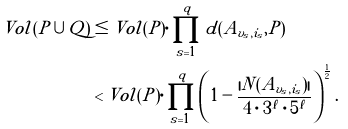<formula> <loc_0><loc_0><loc_500><loc_500>V o l ( P \cup Q ) & \leq V o l ( P ) \cdot \prod _ { s = 1 } ^ { q } d ( A _ { v _ { s } , i _ { s } } , P ) \\ & < V o l ( P ) \cdot \prod _ { s = 1 } ^ { q } \left ( 1 - \frac { | N ( A _ { v _ { s } , i _ { s } } ) | } { 4 \cdot 3 ^ { \ell } \cdot 5 ^ { \ell } } \right ) ^ { \frac { 1 } { 2 } } . \\</formula> 